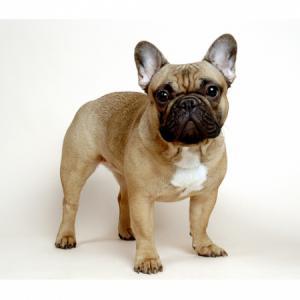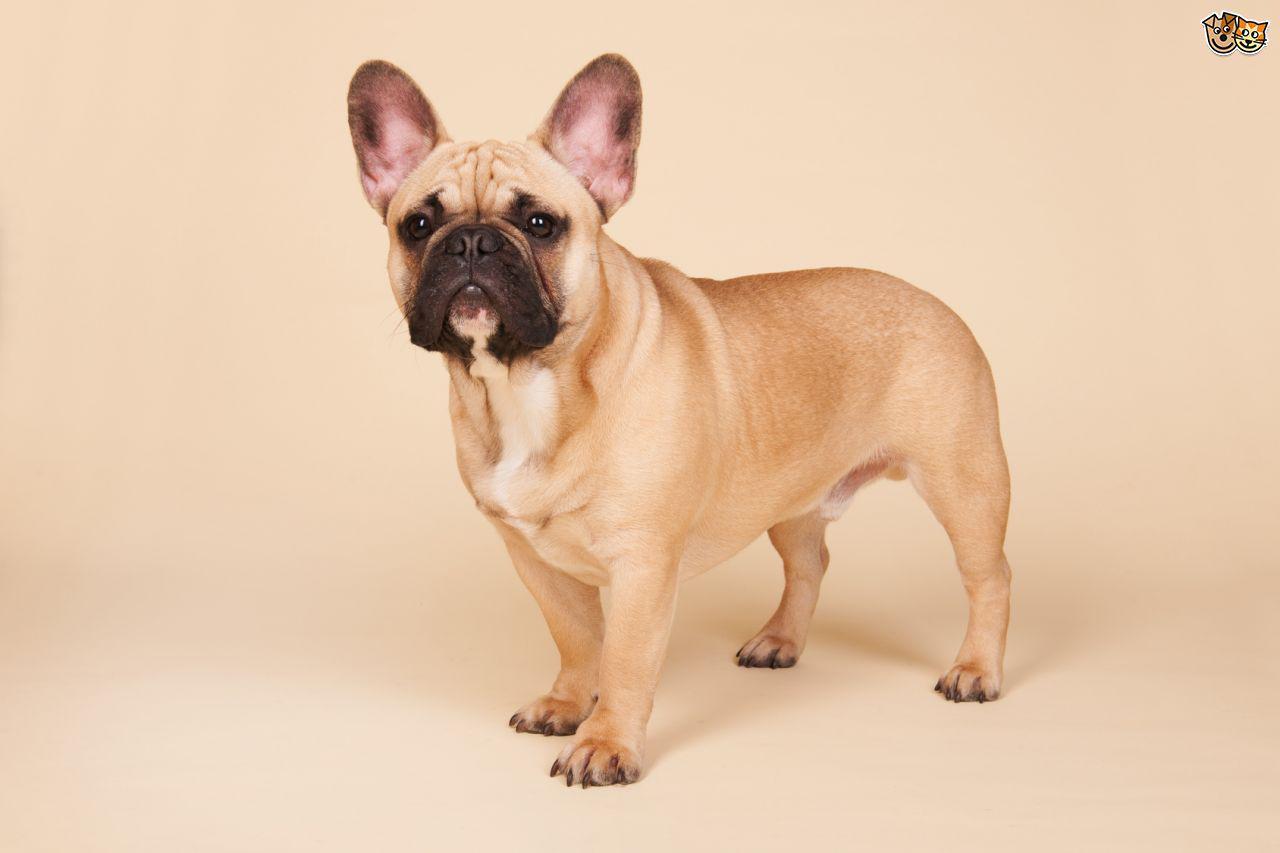The first image is the image on the left, the second image is the image on the right. For the images shown, is this caption "There are eight dog legs visible" true? Answer yes or no. Yes. 